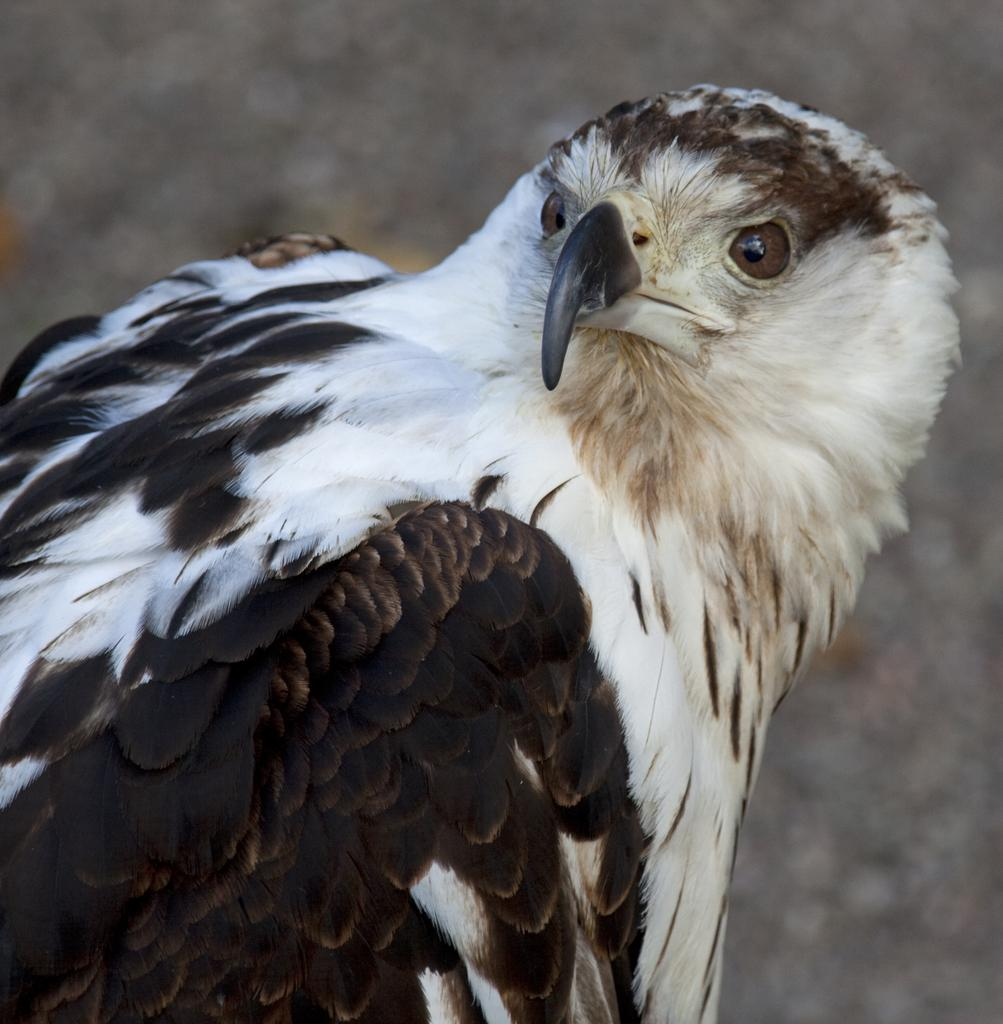What is the main subject in the foreground of the image? There is a bird in the foreground of the image. What can be seen in the background of the image? There are trees in the background of the image. What type of pen is the bird holding in the image? There is no pen present in the image, as it features a bird in the foreground and trees in the background. 